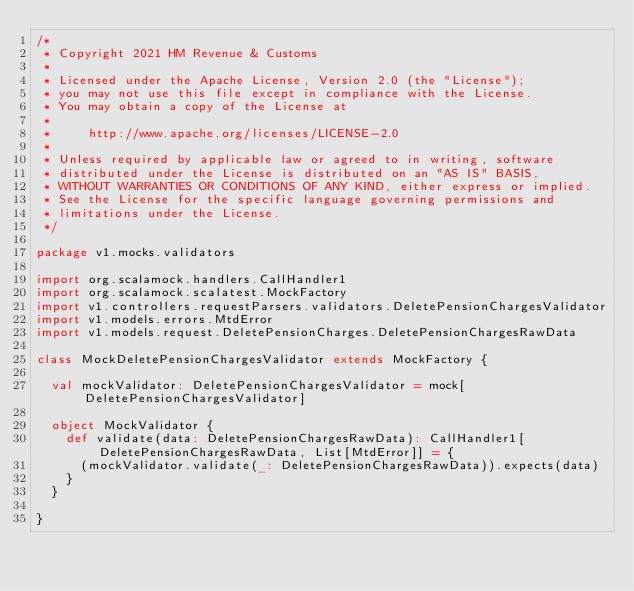Convert code to text. <code><loc_0><loc_0><loc_500><loc_500><_Scala_>/*
 * Copyright 2021 HM Revenue & Customs
 *
 * Licensed under the Apache License, Version 2.0 (the "License");
 * you may not use this file except in compliance with the License.
 * You may obtain a copy of the License at
 *
 *     http://www.apache.org/licenses/LICENSE-2.0
 *
 * Unless required by applicable law or agreed to in writing, software
 * distributed under the License is distributed on an "AS IS" BASIS,
 * WITHOUT WARRANTIES OR CONDITIONS OF ANY KIND, either express or implied.
 * See the License for the specific language governing permissions and
 * limitations under the License.
 */

package v1.mocks.validators

import org.scalamock.handlers.CallHandler1
import org.scalamock.scalatest.MockFactory
import v1.controllers.requestParsers.validators.DeletePensionChargesValidator
import v1.models.errors.MtdError
import v1.models.request.DeletePensionCharges.DeletePensionChargesRawData

class MockDeletePensionChargesValidator extends MockFactory {

  val mockValidator: DeletePensionChargesValidator = mock[DeletePensionChargesValidator]

  object MockValidator {
    def validate(data: DeletePensionChargesRawData): CallHandler1[DeletePensionChargesRawData, List[MtdError]] = {
      (mockValidator.validate(_: DeletePensionChargesRawData)).expects(data)
    }
  }

}</code> 